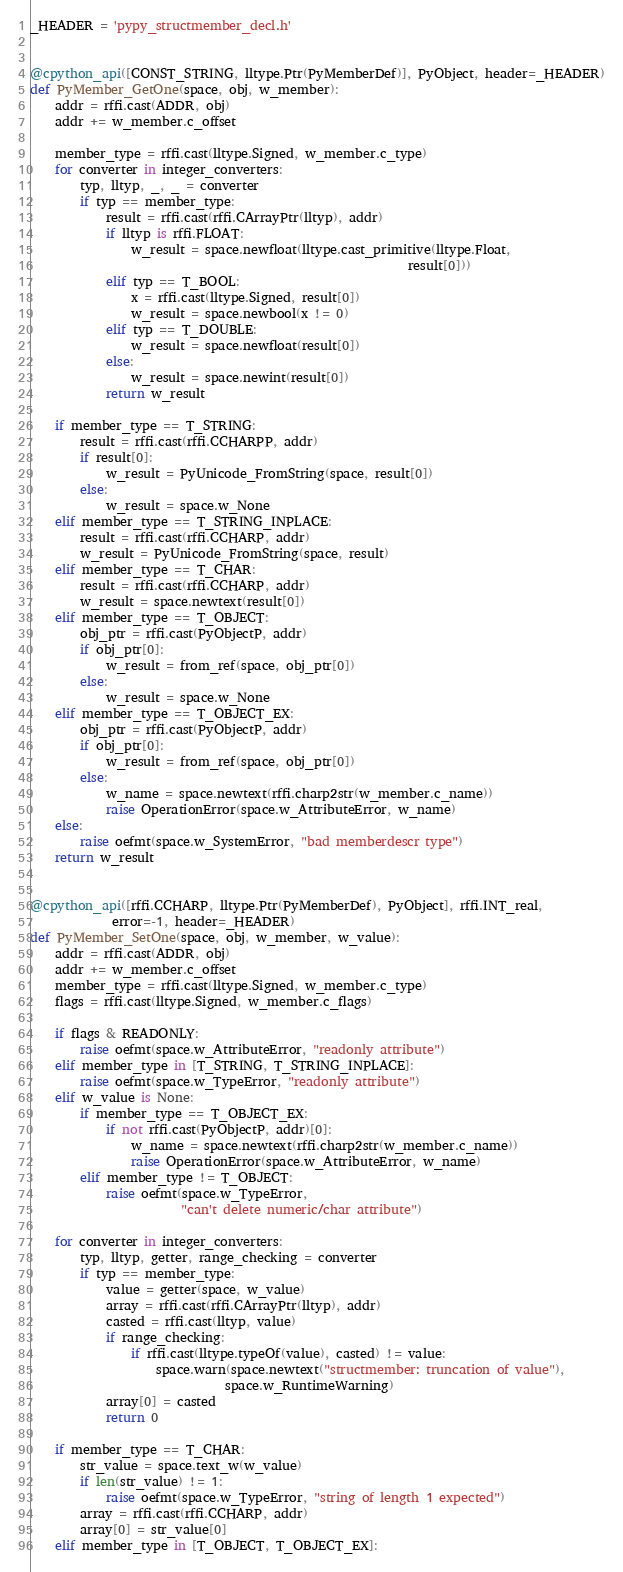<code> <loc_0><loc_0><loc_500><loc_500><_Python_>
_HEADER = 'pypy_structmember_decl.h'


@cpython_api([CONST_STRING, lltype.Ptr(PyMemberDef)], PyObject, header=_HEADER)
def PyMember_GetOne(space, obj, w_member):
    addr = rffi.cast(ADDR, obj)
    addr += w_member.c_offset

    member_type = rffi.cast(lltype.Signed, w_member.c_type)
    for converter in integer_converters:
        typ, lltyp, _, _ = converter
        if typ == member_type:
            result = rffi.cast(rffi.CArrayPtr(lltyp), addr)
            if lltyp is rffi.FLOAT:
                w_result = space.newfloat(lltype.cast_primitive(lltype.Float,
                                                            result[0]))
            elif typ == T_BOOL:
                x = rffi.cast(lltype.Signed, result[0])
                w_result = space.newbool(x != 0)
            elif typ == T_DOUBLE:
                w_result = space.newfloat(result[0])
            else:
                w_result = space.newint(result[0])
            return w_result

    if member_type == T_STRING:
        result = rffi.cast(rffi.CCHARPP, addr)
        if result[0]:
            w_result = PyUnicode_FromString(space, result[0])
        else:
            w_result = space.w_None
    elif member_type == T_STRING_INPLACE:
        result = rffi.cast(rffi.CCHARP, addr)
        w_result = PyUnicode_FromString(space, result)
    elif member_type == T_CHAR:
        result = rffi.cast(rffi.CCHARP, addr)
        w_result = space.newtext(result[0])
    elif member_type == T_OBJECT:
        obj_ptr = rffi.cast(PyObjectP, addr)
        if obj_ptr[0]:
            w_result = from_ref(space, obj_ptr[0])
        else:
            w_result = space.w_None
    elif member_type == T_OBJECT_EX:
        obj_ptr = rffi.cast(PyObjectP, addr)
        if obj_ptr[0]:
            w_result = from_ref(space, obj_ptr[0])
        else:
            w_name = space.newtext(rffi.charp2str(w_member.c_name))
            raise OperationError(space.w_AttributeError, w_name)
    else:
        raise oefmt(space.w_SystemError, "bad memberdescr type")
    return w_result


@cpython_api([rffi.CCHARP, lltype.Ptr(PyMemberDef), PyObject], rffi.INT_real,
             error=-1, header=_HEADER)
def PyMember_SetOne(space, obj, w_member, w_value):
    addr = rffi.cast(ADDR, obj)
    addr += w_member.c_offset
    member_type = rffi.cast(lltype.Signed, w_member.c_type)
    flags = rffi.cast(lltype.Signed, w_member.c_flags)

    if flags & READONLY:
        raise oefmt(space.w_AttributeError, "readonly attribute")
    elif member_type in [T_STRING, T_STRING_INPLACE]:
        raise oefmt(space.w_TypeError, "readonly attribute")
    elif w_value is None:
        if member_type == T_OBJECT_EX:
            if not rffi.cast(PyObjectP, addr)[0]:
                w_name = space.newtext(rffi.charp2str(w_member.c_name))
                raise OperationError(space.w_AttributeError, w_name)
        elif member_type != T_OBJECT:
            raise oefmt(space.w_TypeError,
                        "can't delete numeric/char attribute")

    for converter in integer_converters:
        typ, lltyp, getter, range_checking = converter
        if typ == member_type:
            value = getter(space, w_value)
            array = rffi.cast(rffi.CArrayPtr(lltyp), addr)
            casted = rffi.cast(lltyp, value)
            if range_checking:
                if rffi.cast(lltype.typeOf(value), casted) != value:
                    space.warn(space.newtext("structmember: truncation of value"),
                               space.w_RuntimeWarning)
            array[0] = casted
            return 0

    if member_type == T_CHAR:
        str_value = space.text_w(w_value)
        if len(str_value) != 1:
            raise oefmt(space.w_TypeError, "string of length 1 expected")
        array = rffi.cast(rffi.CCHARP, addr)
        array[0] = str_value[0]
    elif member_type in [T_OBJECT, T_OBJECT_EX]:</code> 